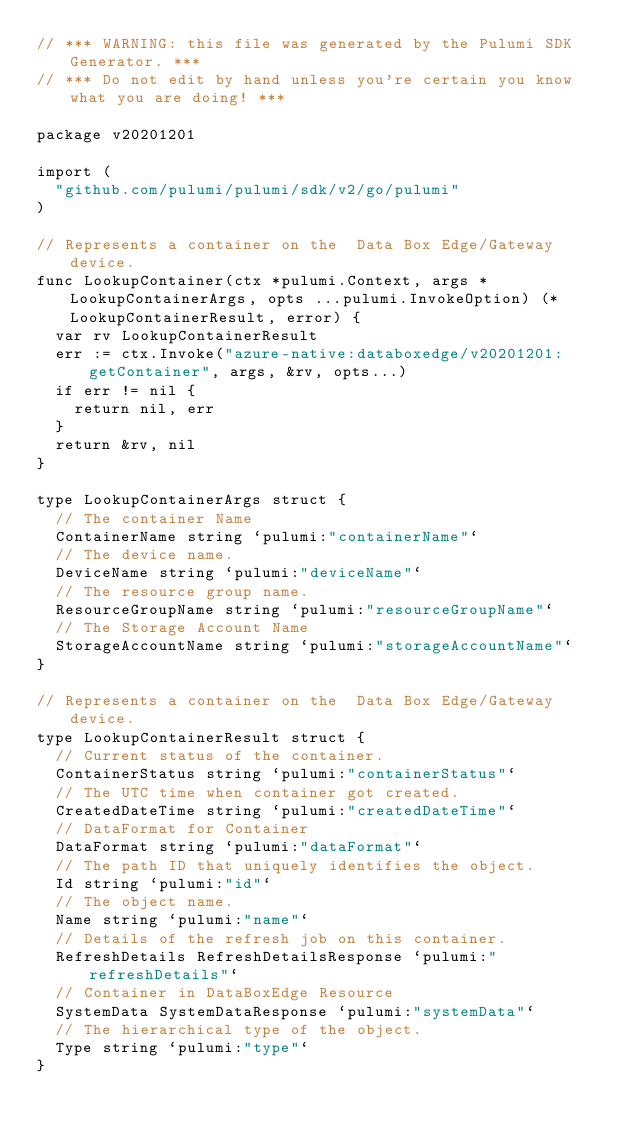Convert code to text. <code><loc_0><loc_0><loc_500><loc_500><_Go_>// *** WARNING: this file was generated by the Pulumi SDK Generator. ***
// *** Do not edit by hand unless you're certain you know what you are doing! ***

package v20201201

import (
	"github.com/pulumi/pulumi/sdk/v2/go/pulumi"
)

// Represents a container on the  Data Box Edge/Gateway device.
func LookupContainer(ctx *pulumi.Context, args *LookupContainerArgs, opts ...pulumi.InvokeOption) (*LookupContainerResult, error) {
	var rv LookupContainerResult
	err := ctx.Invoke("azure-native:databoxedge/v20201201:getContainer", args, &rv, opts...)
	if err != nil {
		return nil, err
	}
	return &rv, nil
}

type LookupContainerArgs struct {
	// The container Name
	ContainerName string `pulumi:"containerName"`
	// The device name.
	DeviceName string `pulumi:"deviceName"`
	// The resource group name.
	ResourceGroupName string `pulumi:"resourceGroupName"`
	// The Storage Account Name
	StorageAccountName string `pulumi:"storageAccountName"`
}

// Represents a container on the  Data Box Edge/Gateway device.
type LookupContainerResult struct {
	// Current status of the container.
	ContainerStatus string `pulumi:"containerStatus"`
	// The UTC time when container got created.
	CreatedDateTime string `pulumi:"createdDateTime"`
	// DataFormat for Container
	DataFormat string `pulumi:"dataFormat"`
	// The path ID that uniquely identifies the object.
	Id string `pulumi:"id"`
	// The object name.
	Name string `pulumi:"name"`
	// Details of the refresh job on this container.
	RefreshDetails RefreshDetailsResponse `pulumi:"refreshDetails"`
	// Container in DataBoxEdge Resource
	SystemData SystemDataResponse `pulumi:"systemData"`
	// The hierarchical type of the object.
	Type string `pulumi:"type"`
}
</code> 